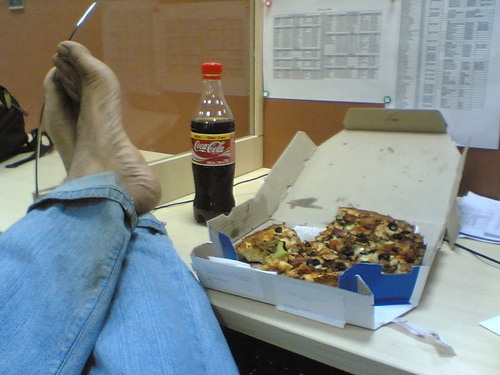Describe the objects in this image and their specific colors. I can see people in gray and darkgray tones, pizza in gray, olive, and black tones, and bottle in gray, black, and tan tones in this image. 